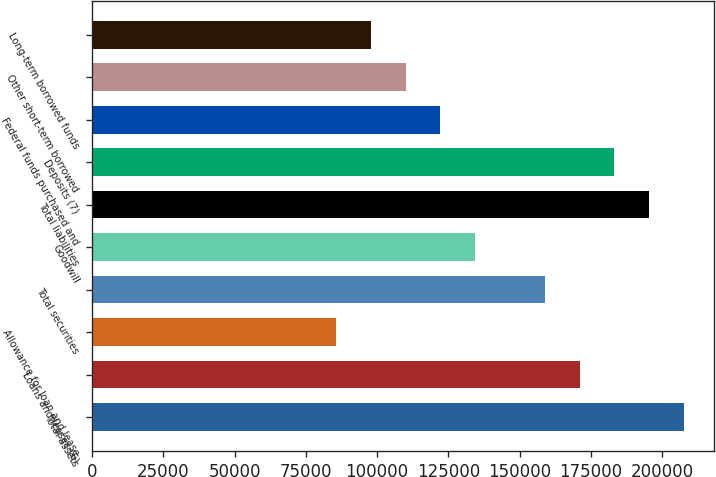<chart> <loc_0><loc_0><loc_500><loc_500><bar_chart><fcel>Total assets<fcel>Loans and leases (6)<fcel>Allowance for loan and lease<fcel>Total securities<fcel>Goodwill<fcel>Total liabilities<fcel>Deposits (7)<fcel>Federal funds purchased and<fcel>Other short-term borrowed<fcel>Long-term borrowed funds<nl><fcel>207661<fcel>171015<fcel>85508.2<fcel>158800<fcel>134369<fcel>195446<fcel>183230<fcel>122154<fcel>109939<fcel>97723.5<nl></chart> 